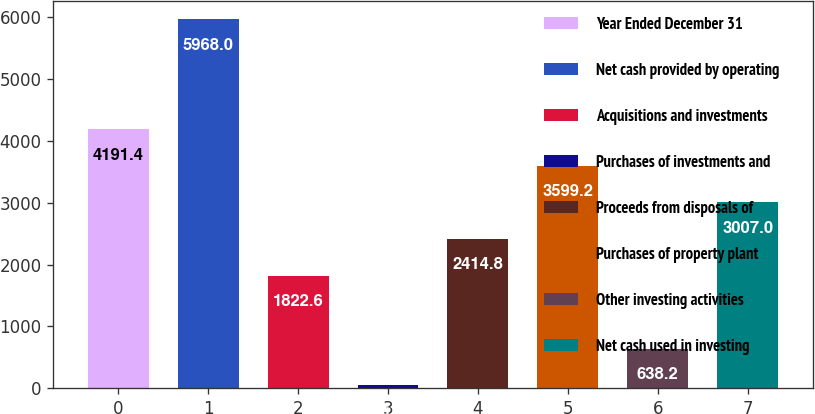Convert chart to OTSL. <chart><loc_0><loc_0><loc_500><loc_500><bar_chart><fcel>Year Ended December 31<fcel>Net cash provided by operating<fcel>Acquisitions and investments<fcel>Purchases of investments and<fcel>Proceeds from disposals of<fcel>Purchases of property plant<fcel>Other investing activities<fcel>Net cash used in investing<nl><fcel>4191.4<fcel>5968<fcel>1822.6<fcel>46<fcel>2414.8<fcel>3599.2<fcel>638.2<fcel>3007<nl></chart> 